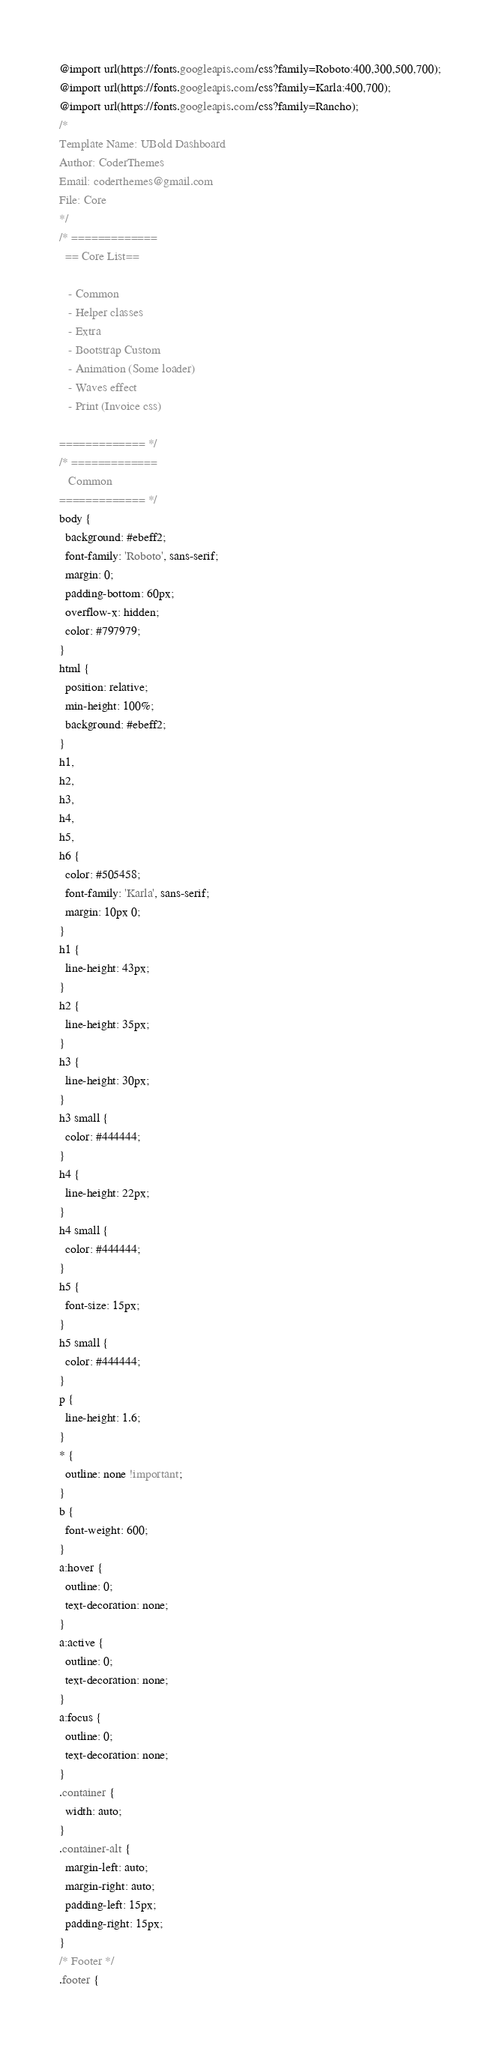<code> <loc_0><loc_0><loc_500><loc_500><_CSS_>@import url(https://fonts.googleapis.com/css?family=Roboto:400,300,500,700);
@import url(https://fonts.googleapis.com/css?family=Karla:400,700);
@import url(https://fonts.googleapis.com/css?family=Rancho);
/*
Template Name: UBold Dashboard
Author: CoderThemes
Email: coderthemes@gmail.com
File: Core
*/
/* =============
  == Core List==

   - Common
   - Helper classes
   - Extra
   - Bootstrap Custom
   - Animation (Some loader)
   - Waves effect
   - Print (Invoice css)

============= */
/* =============
   Common
============= */
body {
  background: #ebeff2;
  font-family: 'Roboto', sans-serif;
  margin: 0;
  padding-bottom: 60px;
  overflow-x: hidden;
  color: #797979;
}
html {
  position: relative;
  min-height: 100%;
  background: #ebeff2;
}
h1,
h2,
h3,
h4,
h5,
h6 {
  color: #505458;
  font-family: 'Karla', sans-serif;
  margin: 10px 0;
}
h1 {
  line-height: 43px;
}
h2 {
  line-height: 35px;
}
h3 {
  line-height: 30px;
}
h3 small {
  color: #444444;
}
h4 {
  line-height: 22px;
}
h4 small {
  color: #444444;
}
h5 {
  font-size: 15px;
}
h5 small {
  color: #444444;
}
p {
  line-height: 1.6;
}
* {
  outline: none !important;
}
b {
  font-weight: 600;
}
a:hover {
  outline: 0;
  text-decoration: none;
}
a:active {
  outline: 0;
  text-decoration: none;
}
a:focus {
  outline: 0;
  text-decoration: none;
}
.container {
  width: auto;
}
.container-alt {
  margin-left: auto;
  margin-right: auto;
  padding-left: 15px;
  padding-right: 15px;
}
/* Footer */
.footer {</code> 